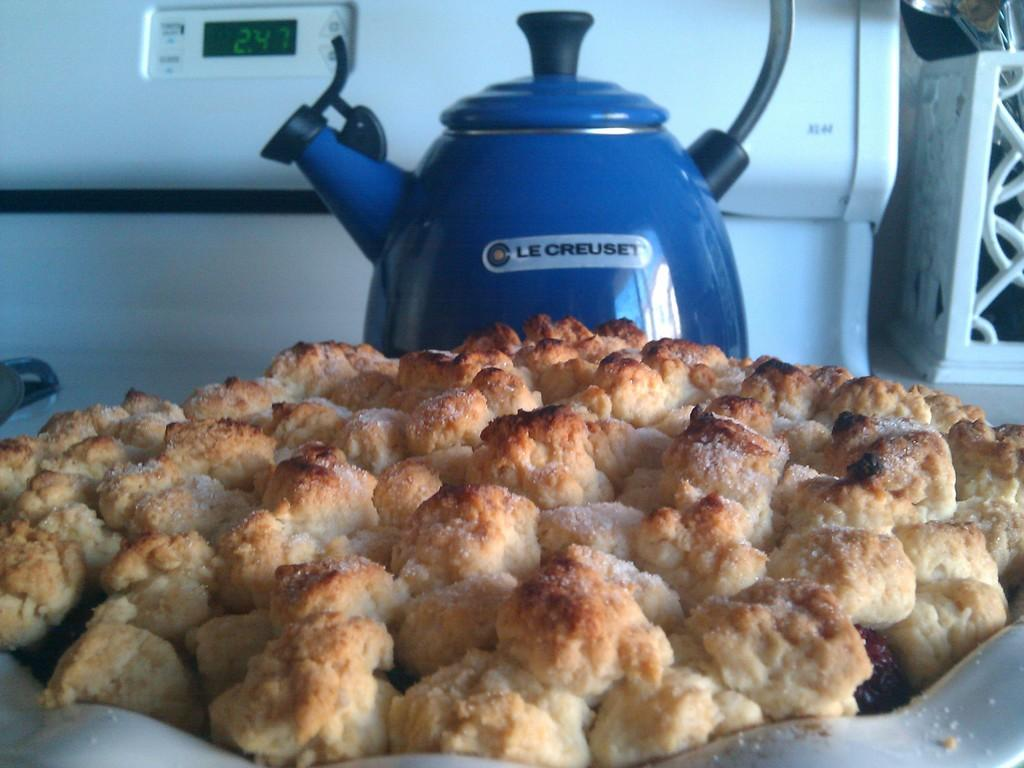What types of food items can be seen in the image? There are food items in the image, but their specific types cannot be determined from the provided facts. What is the jar used for in the image? The purpose of the jar in the image cannot be determined from the provided facts. What is the device with digital numbers used for in the image? The device with digital numbers is likely used for displaying time, temperature, or other measurements, but its specific function cannot be determined from the provided facts. Can you describe the object on the right side of the image? The object on the right side of the image cannot be described in detail based on the provided facts. What type of office furniture is present in the image? There is no mention of office furniture in the provided facts, and therefore it cannot be determined if any is present in the image. 